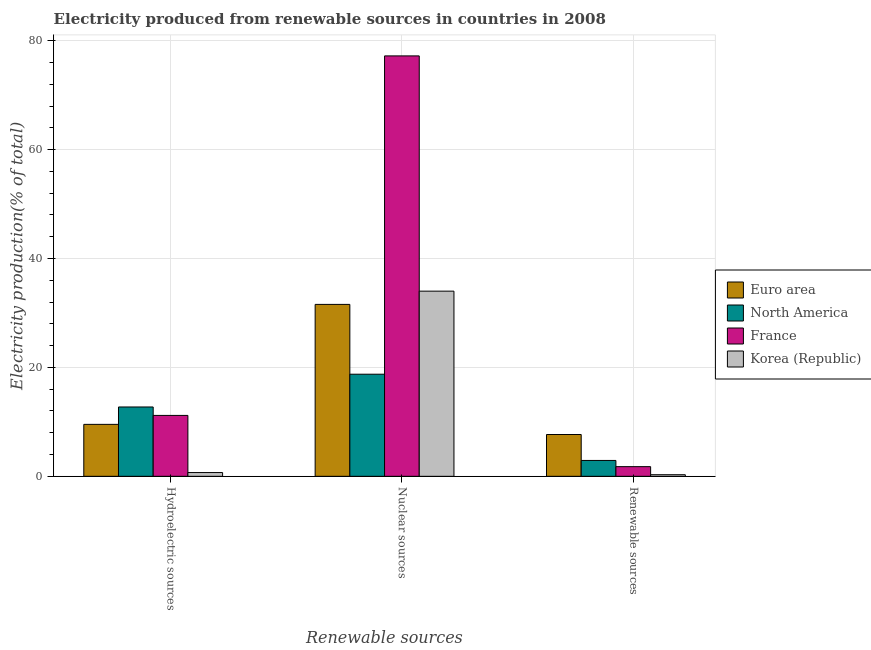How many different coloured bars are there?
Your response must be concise. 4. How many groups of bars are there?
Ensure brevity in your answer.  3. Are the number of bars on each tick of the X-axis equal?
Offer a terse response. Yes. How many bars are there on the 1st tick from the right?
Keep it short and to the point. 4. What is the label of the 3rd group of bars from the left?
Make the answer very short. Renewable sources. What is the percentage of electricity produced by nuclear sources in Korea (Republic)?
Provide a short and direct response. 34. Across all countries, what is the maximum percentage of electricity produced by nuclear sources?
Your response must be concise. 77.21. Across all countries, what is the minimum percentage of electricity produced by hydroelectric sources?
Your answer should be compact. 0.69. In which country was the percentage of electricity produced by hydroelectric sources maximum?
Ensure brevity in your answer.  North America. What is the total percentage of electricity produced by hydroelectric sources in the graph?
Offer a very short reply. 34.15. What is the difference between the percentage of electricity produced by renewable sources in Korea (Republic) and that in Euro area?
Your answer should be very brief. -7.38. What is the difference between the percentage of electricity produced by renewable sources in Korea (Republic) and the percentage of electricity produced by nuclear sources in Euro area?
Provide a short and direct response. -31.28. What is the average percentage of electricity produced by hydroelectric sources per country?
Your answer should be very brief. 8.54. What is the difference between the percentage of electricity produced by nuclear sources and percentage of electricity produced by renewable sources in Euro area?
Your response must be concise. 23.89. In how many countries, is the percentage of electricity produced by renewable sources greater than 60 %?
Provide a short and direct response. 0. What is the ratio of the percentage of electricity produced by renewable sources in North America to that in France?
Offer a very short reply. 1.64. Is the difference between the percentage of electricity produced by nuclear sources in North America and Euro area greater than the difference between the percentage of electricity produced by hydroelectric sources in North America and Euro area?
Offer a terse response. No. What is the difference between the highest and the second highest percentage of electricity produced by nuclear sources?
Give a very brief answer. 43.2. What is the difference between the highest and the lowest percentage of electricity produced by renewable sources?
Make the answer very short. 7.38. Is the sum of the percentage of electricity produced by hydroelectric sources in North America and Korea (Republic) greater than the maximum percentage of electricity produced by renewable sources across all countries?
Offer a very short reply. Yes. What does the 3rd bar from the right in Nuclear sources represents?
Make the answer very short. North America. Is it the case that in every country, the sum of the percentage of electricity produced by hydroelectric sources and percentage of electricity produced by nuclear sources is greater than the percentage of electricity produced by renewable sources?
Offer a terse response. Yes. How many bars are there?
Provide a succinct answer. 12. Does the graph contain any zero values?
Your answer should be compact. No. Does the graph contain grids?
Ensure brevity in your answer.  Yes. Where does the legend appear in the graph?
Offer a very short reply. Center right. What is the title of the graph?
Provide a short and direct response. Electricity produced from renewable sources in countries in 2008. Does "Macedonia" appear as one of the legend labels in the graph?
Provide a short and direct response. No. What is the label or title of the X-axis?
Make the answer very short. Renewable sources. What is the label or title of the Y-axis?
Offer a very short reply. Electricity production(% of total). What is the Electricity production(% of total) of Euro area in Hydroelectric sources?
Your response must be concise. 9.54. What is the Electricity production(% of total) of North America in Hydroelectric sources?
Give a very brief answer. 12.73. What is the Electricity production(% of total) in France in Hydroelectric sources?
Your response must be concise. 11.18. What is the Electricity production(% of total) of Korea (Republic) in Hydroelectric sources?
Offer a terse response. 0.69. What is the Electricity production(% of total) in Euro area in Nuclear sources?
Give a very brief answer. 31.57. What is the Electricity production(% of total) in North America in Nuclear sources?
Make the answer very short. 18.75. What is the Electricity production(% of total) of France in Nuclear sources?
Your answer should be compact. 77.21. What is the Electricity production(% of total) of Korea (Republic) in Nuclear sources?
Offer a terse response. 34. What is the Electricity production(% of total) of Euro area in Renewable sources?
Offer a terse response. 7.68. What is the Electricity production(% of total) of North America in Renewable sources?
Offer a terse response. 2.92. What is the Electricity production(% of total) in France in Renewable sources?
Offer a very short reply. 1.78. What is the Electricity production(% of total) of Korea (Republic) in Renewable sources?
Your response must be concise. 0.29. Across all Renewable sources, what is the maximum Electricity production(% of total) in Euro area?
Ensure brevity in your answer.  31.57. Across all Renewable sources, what is the maximum Electricity production(% of total) of North America?
Offer a very short reply. 18.75. Across all Renewable sources, what is the maximum Electricity production(% of total) in France?
Your answer should be compact. 77.21. Across all Renewable sources, what is the maximum Electricity production(% of total) of Korea (Republic)?
Your response must be concise. 34. Across all Renewable sources, what is the minimum Electricity production(% of total) of Euro area?
Ensure brevity in your answer.  7.68. Across all Renewable sources, what is the minimum Electricity production(% of total) in North America?
Make the answer very short. 2.92. Across all Renewable sources, what is the minimum Electricity production(% of total) of France?
Your response must be concise. 1.78. Across all Renewable sources, what is the minimum Electricity production(% of total) in Korea (Republic)?
Offer a terse response. 0.29. What is the total Electricity production(% of total) in Euro area in the graph?
Offer a very short reply. 48.79. What is the total Electricity production(% of total) in North America in the graph?
Provide a succinct answer. 34.4. What is the total Electricity production(% of total) of France in the graph?
Your answer should be compact. 90.17. What is the total Electricity production(% of total) of Korea (Republic) in the graph?
Make the answer very short. 34.99. What is the difference between the Electricity production(% of total) of Euro area in Hydroelectric sources and that in Nuclear sources?
Your answer should be compact. -22.03. What is the difference between the Electricity production(% of total) in North America in Hydroelectric sources and that in Nuclear sources?
Offer a very short reply. -6.02. What is the difference between the Electricity production(% of total) in France in Hydroelectric sources and that in Nuclear sources?
Keep it short and to the point. -66.02. What is the difference between the Electricity production(% of total) of Korea (Republic) in Hydroelectric sources and that in Nuclear sources?
Your answer should be very brief. -33.31. What is the difference between the Electricity production(% of total) of Euro area in Hydroelectric sources and that in Renewable sources?
Keep it short and to the point. 1.86. What is the difference between the Electricity production(% of total) of North America in Hydroelectric sources and that in Renewable sources?
Offer a terse response. 9.82. What is the difference between the Electricity production(% of total) of France in Hydroelectric sources and that in Renewable sources?
Ensure brevity in your answer.  9.41. What is the difference between the Electricity production(% of total) of Korea (Republic) in Hydroelectric sources and that in Renewable sources?
Provide a short and direct response. 0.4. What is the difference between the Electricity production(% of total) of Euro area in Nuclear sources and that in Renewable sources?
Your answer should be compact. 23.89. What is the difference between the Electricity production(% of total) of North America in Nuclear sources and that in Renewable sources?
Provide a succinct answer. 15.83. What is the difference between the Electricity production(% of total) of France in Nuclear sources and that in Renewable sources?
Offer a terse response. 75.43. What is the difference between the Electricity production(% of total) of Korea (Republic) in Nuclear sources and that in Renewable sources?
Your answer should be compact. 33.71. What is the difference between the Electricity production(% of total) of Euro area in Hydroelectric sources and the Electricity production(% of total) of North America in Nuclear sources?
Ensure brevity in your answer.  -9.21. What is the difference between the Electricity production(% of total) of Euro area in Hydroelectric sources and the Electricity production(% of total) of France in Nuclear sources?
Offer a very short reply. -67.67. What is the difference between the Electricity production(% of total) of Euro area in Hydroelectric sources and the Electricity production(% of total) of Korea (Republic) in Nuclear sources?
Keep it short and to the point. -24.46. What is the difference between the Electricity production(% of total) in North America in Hydroelectric sources and the Electricity production(% of total) in France in Nuclear sources?
Provide a succinct answer. -64.47. What is the difference between the Electricity production(% of total) in North America in Hydroelectric sources and the Electricity production(% of total) in Korea (Republic) in Nuclear sources?
Your answer should be compact. -21.27. What is the difference between the Electricity production(% of total) in France in Hydroelectric sources and the Electricity production(% of total) in Korea (Republic) in Nuclear sources?
Provide a succinct answer. -22.82. What is the difference between the Electricity production(% of total) of Euro area in Hydroelectric sources and the Electricity production(% of total) of North America in Renewable sources?
Provide a short and direct response. 6.62. What is the difference between the Electricity production(% of total) in Euro area in Hydroelectric sources and the Electricity production(% of total) in France in Renewable sources?
Your answer should be compact. 7.76. What is the difference between the Electricity production(% of total) in Euro area in Hydroelectric sources and the Electricity production(% of total) in Korea (Republic) in Renewable sources?
Keep it short and to the point. 9.25. What is the difference between the Electricity production(% of total) in North America in Hydroelectric sources and the Electricity production(% of total) in France in Renewable sources?
Provide a short and direct response. 10.96. What is the difference between the Electricity production(% of total) in North America in Hydroelectric sources and the Electricity production(% of total) in Korea (Republic) in Renewable sources?
Ensure brevity in your answer.  12.44. What is the difference between the Electricity production(% of total) of France in Hydroelectric sources and the Electricity production(% of total) of Korea (Republic) in Renewable sources?
Your answer should be very brief. 10.89. What is the difference between the Electricity production(% of total) in Euro area in Nuclear sources and the Electricity production(% of total) in North America in Renewable sources?
Your response must be concise. 28.65. What is the difference between the Electricity production(% of total) in Euro area in Nuclear sources and the Electricity production(% of total) in France in Renewable sources?
Ensure brevity in your answer.  29.79. What is the difference between the Electricity production(% of total) of Euro area in Nuclear sources and the Electricity production(% of total) of Korea (Republic) in Renewable sources?
Your answer should be compact. 31.28. What is the difference between the Electricity production(% of total) of North America in Nuclear sources and the Electricity production(% of total) of France in Renewable sources?
Provide a short and direct response. 16.97. What is the difference between the Electricity production(% of total) in North America in Nuclear sources and the Electricity production(% of total) in Korea (Republic) in Renewable sources?
Give a very brief answer. 18.46. What is the difference between the Electricity production(% of total) of France in Nuclear sources and the Electricity production(% of total) of Korea (Republic) in Renewable sources?
Your response must be concise. 76.91. What is the average Electricity production(% of total) in Euro area per Renewable sources?
Provide a succinct answer. 16.26. What is the average Electricity production(% of total) in North America per Renewable sources?
Your answer should be compact. 11.47. What is the average Electricity production(% of total) in France per Renewable sources?
Ensure brevity in your answer.  30.06. What is the average Electricity production(% of total) in Korea (Republic) per Renewable sources?
Provide a succinct answer. 11.66. What is the difference between the Electricity production(% of total) of Euro area and Electricity production(% of total) of North America in Hydroelectric sources?
Offer a terse response. -3.19. What is the difference between the Electricity production(% of total) of Euro area and Electricity production(% of total) of France in Hydroelectric sources?
Give a very brief answer. -1.64. What is the difference between the Electricity production(% of total) of Euro area and Electricity production(% of total) of Korea (Republic) in Hydroelectric sources?
Provide a succinct answer. 8.85. What is the difference between the Electricity production(% of total) of North America and Electricity production(% of total) of France in Hydroelectric sources?
Provide a succinct answer. 1.55. What is the difference between the Electricity production(% of total) of North America and Electricity production(% of total) of Korea (Republic) in Hydroelectric sources?
Ensure brevity in your answer.  12.04. What is the difference between the Electricity production(% of total) in France and Electricity production(% of total) in Korea (Republic) in Hydroelectric sources?
Your answer should be compact. 10.49. What is the difference between the Electricity production(% of total) of Euro area and Electricity production(% of total) of North America in Nuclear sources?
Your answer should be compact. 12.82. What is the difference between the Electricity production(% of total) in Euro area and Electricity production(% of total) in France in Nuclear sources?
Offer a terse response. -45.64. What is the difference between the Electricity production(% of total) of Euro area and Electricity production(% of total) of Korea (Republic) in Nuclear sources?
Offer a terse response. -2.43. What is the difference between the Electricity production(% of total) of North America and Electricity production(% of total) of France in Nuclear sources?
Make the answer very short. -58.46. What is the difference between the Electricity production(% of total) in North America and Electricity production(% of total) in Korea (Republic) in Nuclear sources?
Give a very brief answer. -15.25. What is the difference between the Electricity production(% of total) of France and Electricity production(% of total) of Korea (Republic) in Nuclear sources?
Your answer should be compact. 43.2. What is the difference between the Electricity production(% of total) in Euro area and Electricity production(% of total) in North America in Renewable sources?
Your answer should be compact. 4.76. What is the difference between the Electricity production(% of total) of Euro area and Electricity production(% of total) of France in Renewable sources?
Offer a terse response. 5.9. What is the difference between the Electricity production(% of total) of Euro area and Electricity production(% of total) of Korea (Republic) in Renewable sources?
Your answer should be very brief. 7.38. What is the difference between the Electricity production(% of total) of North America and Electricity production(% of total) of France in Renewable sources?
Your answer should be very brief. 1.14. What is the difference between the Electricity production(% of total) in North America and Electricity production(% of total) in Korea (Republic) in Renewable sources?
Make the answer very short. 2.62. What is the difference between the Electricity production(% of total) of France and Electricity production(% of total) of Korea (Republic) in Renewable sources?
Ensure brevity in your answer.  1.48. What is the ratio of the Electricity production(% of total) in Euro area in Hydroelectric sources to that in Nuclear sources?
Keep it short and to the point. 0.3. What is the ratio of the Electricity production(% of total) in North America in Hydroelectric sources to that in Nuclear sources?
Your answer should be compact. 0.68. What is the ratio of the Electricity production(% of total) of France in Hydroelectric sources to that in Nuclear sources?
Offer a very short reply. 0.14. What is the ratio of the Electricity production(% of total) in Korea (Republic) in Hydroelectric sources to that in Nuclear sources?
Your answer should be compact. 0.02. What is the ratio of the Electricity production(% of total) of Euro area in Hydroelectric sources to that in Renewable sources?
Provide a short and direct response. 1.24. What is the ratio of the Electricity production(% of total) in North America in Hydroelectric sources to that in Renewable sources?
Ensure brevity in your answer.  4.37. What is the ratio of the Electricity production(% of total) in France in Hydroelectric sources to that in Renewable sources?
Your response must be concise. 6.29. What is the ratio of the Electricity production(% of total) of Korea (Republic) in Hydroelectric sources to that in Renewable sources?
Keep it short and to the point. 2.35. What is the ratio of the Electricity production(% of total) of Euro area in Nuclear sources to that in Renewable sources?
Offer a terse response. 4.11. What is the ratio of the Electricity production(% of total) in North America in Nuclear sources to that in Renewable sources?
Offer a terse response. 6.43. What is the ratio of the Electricity production(% of total) in France in Nuclear sources to that in Renewable sources?
Your response must be concise. 43.45. What is the ratio of the Electricity production(% of total) of Korea (Republic) in Nuclear sources to that in Renewable sources?
Offer a terse response. 115.68. What is the difference between the highest and the second highest Electricity production(% of total) of Euro area?
Your answer should be very brief. 22.03. What is the difference between the highest and the second highest Electricity production(% of total) in North America?
Your response must be concise. 6.02. What is the difference between the highest and the second highest Electricity production(% of total) of France?
Your answer should be compact. 66.02. What is the difference between the highest and the second highest Electricity production(% of total) in Korea (Republic)?
Your response must be concise. 33.31. What is the difference between the highest and the lowest Electricity production(% of total) in Euro area?
Provide a succinct answer. 23.89. What is the difference between the highest and the lowest Electricity production(% of total) in North America?
Give a very brief answer. 15.83. What is the difference between the highest and the lowest Electricity production(% of total) in France?
Give a very brief answer. 75.43. What is the difference between the highest and the lowest Electricity production(% of total) in Korea (Republic)?
Your answer should be very brief. 33.71. 